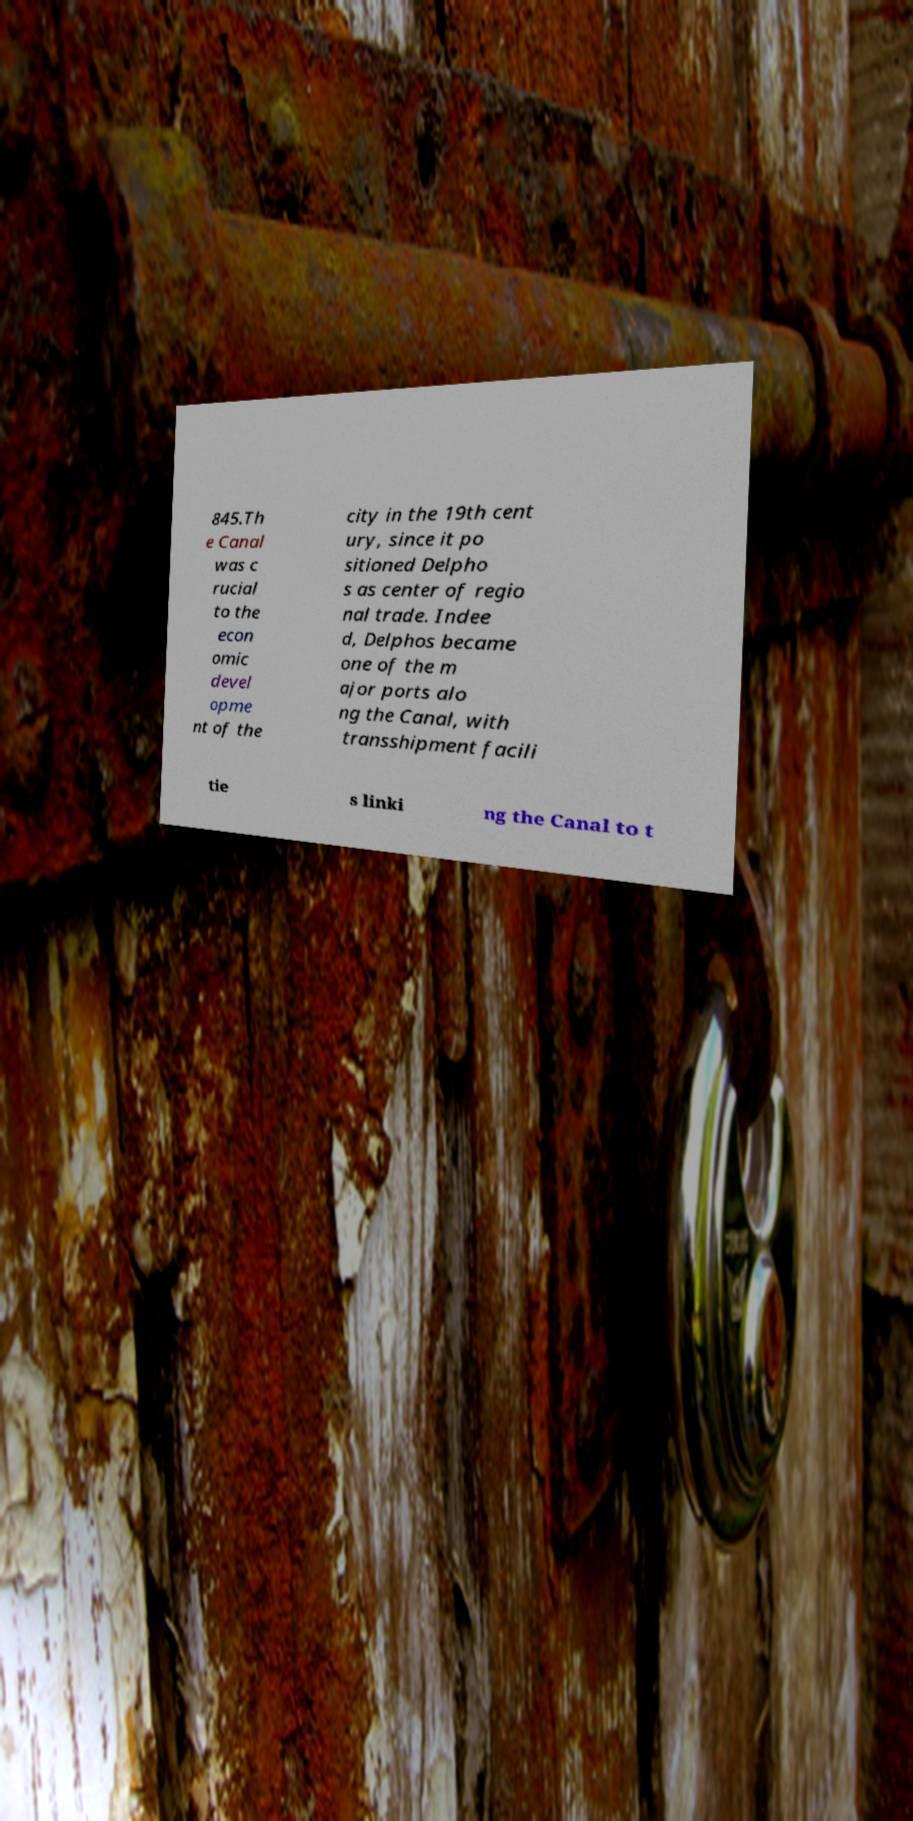Could you assist in decoding the text presented in this image and type it out clearly? 845.Th e Canal was c rucial to the econ omic devel opme nt of the city in the 19th cent ury, since it po sitioned Delpho s as center of regio nal trade. Indee d, Delphos became one of the m ajor ports alo ng the Canal, with transshipment facili tie s linki ng the Canal to t 